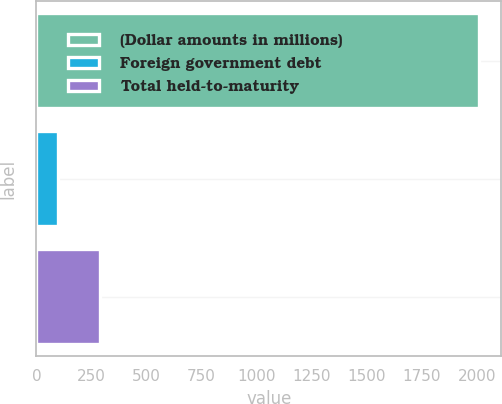Convert chart. <chart><loc_0><loc_0><loc_500><loc_500><bar_chart><fcel>(Dollar amounts in millions)<fcel>Foreign government debt<fcel>Total held-to-maturity<nl><fcel>2010<fcel>100<fcel>291<nl></chart> 